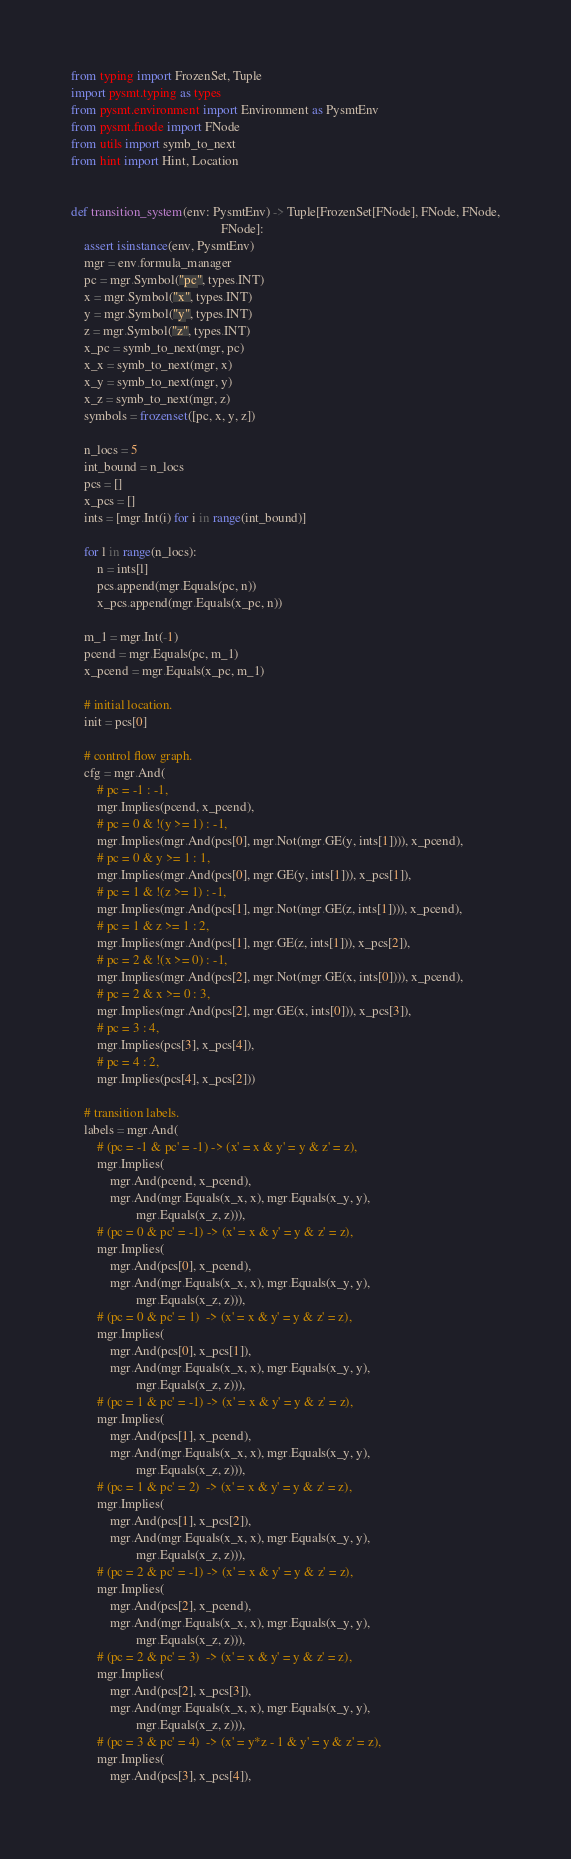<code> <loc_0><loc_0><loc_500><loc_500><_Python_>from typing import FrozenSet, Tuple
import pysmt.typing as types
from pysmt.environment import Environment as PysmtEnv
from pysmt.fnode import FNode
from utils import symb_to_next
from hint import Hint, Location


def transition_system(env: PysmtEnv) -> Tuple[FrozenSet[FNode], FNode, FNode,
                                              FNode]:
    assert isinstance(env, PysmtEnv)
    mgr = env.formula_manager
    pc = mgr.Symbol("pc", types.INT)
    x = mgr.Symbol("x", types.INT)
    y = mgr.Symbol("y", types.INT)
    z = mgr.Symbol("z", types.INT)
    x_pc = symb_to_next(mgr, pc)
    x_x = symb_to_next(mgr, x)
    x_y = symb_to_next(mgr, y)
    x_z = symb_to_next(mgr, z)
    symbols = frozenset([pc, x, y, z])

    n_locs = 5
    int_bound = n_locs
    pcs = []
    x_pcs = []
    ints = [mgr.Int(i) for i in range(int_bound)]

    for l in range(n_locs):
        n = ints[l]
        pcs.append(mgr.Equals(pc, n))
        x_pcs.append(mgr.Equals(x_pc, n))

    m_1 = mgr.Int(-1)
    pcend = mgr.Equals(pc, m_1)
    x_pcend = mgr.Equals(x_pc, m_1)

    # initial location.
    init = pcs[0]

    # control flow graph.
    cfg = mgr.And(
        # pc = -1 : -1,
        mgr.Implies(pcend, x_pcend),
        # pc = 0 & !(y >= 1) : -1,
        mgr.Implies(mgr.And(pcs[0], mgr.Not(mgr.GE(y, ints[1]))), x_pcend),
        # pc = 0 & y >= 1 : 1,
        mgr.Implies(mgr.And(pcs[0], mgr.GE(y, ints[1])), x_pcs[1]),
        # pc = 1 & !(z >= 1) : -1,
        mgr.Implies(mgr.And(pcs[1], mgr.Not(mgr.GE(z, ints[1]))), x_pcend),
        # pc = 1 & z >= 1 : 2,
        mgr.Implies(mgr.And(pcs[1], mgr.GE(z, ints[1])), x_pcs[2]),
        # pc = 2 & !(x >= 0) : -1,
        mgr.Implies(mgr.And(pcs[2], mgr.Not(mgr.GE(x, ints[0]))), x_pcend),
        # pc = 2 & x >= 0 : 3,
        mgr.Implies(mgr.And(pcs[2], mgr.GE(x, ints[0])), x_pcs[3]),
        # pc = 3 : 4,
        mgr.Implies(pcs[3], x_pcs[4]),
        # pc = 4 : 2,
        mgr.Implies(pcs[4], x_pcs[2]))

    # transition labels.
    labels = mgr.And(
        # (pc = -1 & pc' = -1) -> (x' = x & y' = y & z' = z),
        mgr.Implies(
            mgr.And(pcend, x_pcend),
            mgr.And(mgr.Equals(x_x, x), mgr.Equals(x_y, y),
                    mgr.Equals(x_z, z))),
        # (pc = 0 & pc' = -1) -> (x' = x & y' = y & z' = z),
        mgr.Implies(
            mgr.And(pcs[0], x_pcend),
            mgr.And(mgr.Equals(x_x, x), mgr.Equals(x_y, y),
                    mgr.Equals(x_z, z))),
        # (pc = 0 & pc' = 1)  -> (x' = x & y' = y & z' = z),
        mgr.Implies(
            mgr.And(pcs[0], x_pcs[1]),
            mgr.And(mgr.Equals(x_x, x), mgr.Equals(x_y, y),
                    mgr.Equals(x_z, z))),
        # (pc = 1 & pc' = -1) -> (x' = x & y' = y & z' = z),
        mgr.Implies(
            mgr.And(pcs[1], x_pcend),
            mgr.And(mgr.Equals(x_x, x), mgr.Equals(x_y, y),
                    mgr.Equals(x_z, z))),
        # (pc = 1 & pc' = 2)  -> (x' = x & y' = y & z' = z),
        mgr.Implies(
            mgr.And(pcs[1], x_pcs[2]),
            mgr.And(mgr.Equals(x_x, x), mgr.Equals(x_y, y),
                    mgr.Equals(x_z, z))),
        # (pc = 2 & pc' = -1) -> (x' = x & y' = y & z' = z),
        mgr.Implies(
            mgr.And(pcs[2], x_pcend),
            mgr.And(mgr.Equals(x_x, x), mgr.Equals(x_y, y),
                    mgr.Equals(x_z, z))),
        # (pc = 2 & pc' = 3)  -> (x' = x & y' = y & z' = z),
        mgr.Implies(
            mgr.And(pcs[2], x_pcs[3]),
            mgr.And(mgr.Equals(x_x, x), mgr.Equals(x_y, y),
                    mgr.Equals(x_z, z))),
        # (pc = 3 & pc' = 4)  -> (x' = y*z - 1 & y' = y & z' = z),
        mgr.Implies(
            mgr.And(pcs[3], x_pcs[4]),</code> 